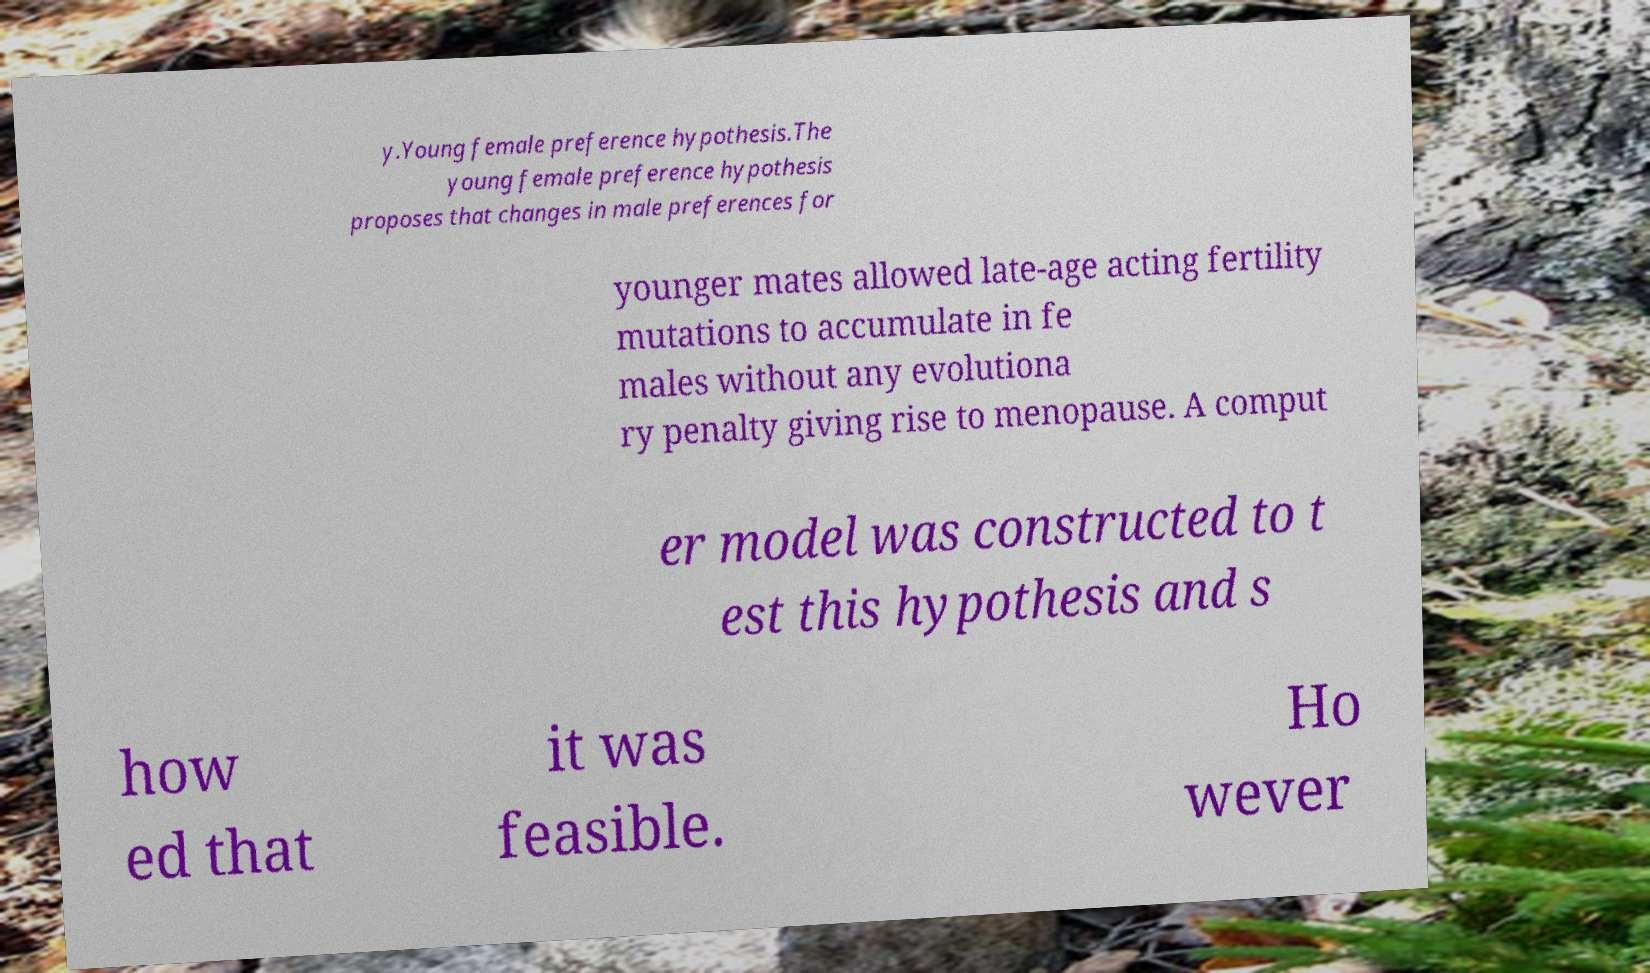Can you read and provide the text displayed in the image?This photo seems to have some interesting text. Can you extract and type it out for me? y.Young female preference hypothesis.The young female preference hypothesis proposes that changes in male preferences for younger mates allowed late-age acting fertility mutations to accumulate in fe males without any evolutiona ry penalty giving rise to menopause. A comput er model was constructed to t est this hypothesis and s how ed that it was feasible. Ho wever 